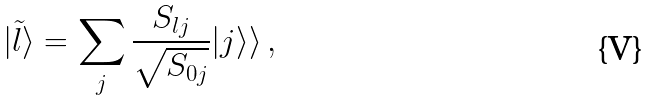Convert formula to latex. <formula><loc_0><loc_0><loc_500><loc_500>| \tilde { l } \rangle = \sum _ { j } \frac { S _ { l j } } { \sqrt { S _ { 0 j } } } | j \rangle \rangle \, ,</formula> 